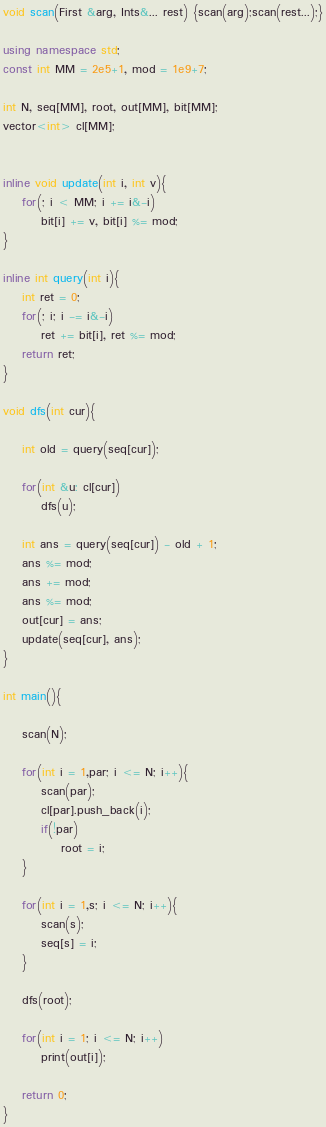<code> <loc_0><loc_0><loc_500><loc_500><_C++_>void scan(First &arg, Ints&... rest) {scan(arg);scan(rest...);}

using namespace std;
const int MM = 2e5+1, mod = 1e9+7;

int N, seq[MM], root, out[MM], bit[MM];
vector<int> cl[MM];


inline void update(int i, int v){
    for(; i < MM; i += i&-i)
        bit[i] += v, bit[i] %= mod;
}

inline int query(int i){
    int ret = 0;
    for(; i; i -= i&-i)
        ret += bit[i], ret %= mod;
    return ret;
}

void dfs(int cur){
    
    int old = query(seq[cur]);
    
    for(int &u: cl[cur])
        dfs(u);
    
    int ans = query(seq[cur]) - old + 1;
    ans %= mod;
    ans += mod;
    ans %= mod;
    out[cur] = ans;
    update(seq[cur], ans);
}

int main(){
    
    scan(N);
    
    for(int i = 1,par; i <= N; i++){
        scan(par);
        cl[par].push_back(i);
        if(!par)
            root = i;
    }
    
    for(int i = 1,s; i <= N; i++){
        scan(s);
        seq[s] = i;
    }
    
    dfs(root);
    
    for(int i = 1; i <= N; i++)
        print(out[i]);
    
    return 0;
}</code> 